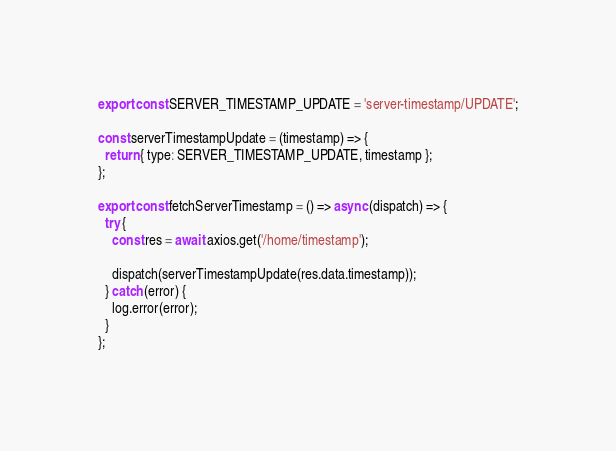Convert code to text. <code><loc_0><loc_0><loc_500><loc_500><_JavaScript_>export const SERVER_TIMESTAMP_UPDATE = 'server-timestamp/UPDATE';

const serverTimestampUpdate = (timestamp) => {
  return { type: SERVER_TIMESTAMP_UPDATE, timestamp };
};

export const fetchServerTimestamp = () => async (dispatch) => {
  try {
    const res = await axios.get('/home/timestamp');

    dispatch(serverTimestampUpdate(res.data.timestamp));
  } catch (error) {
    log.error(error);
  }
};
</code> 